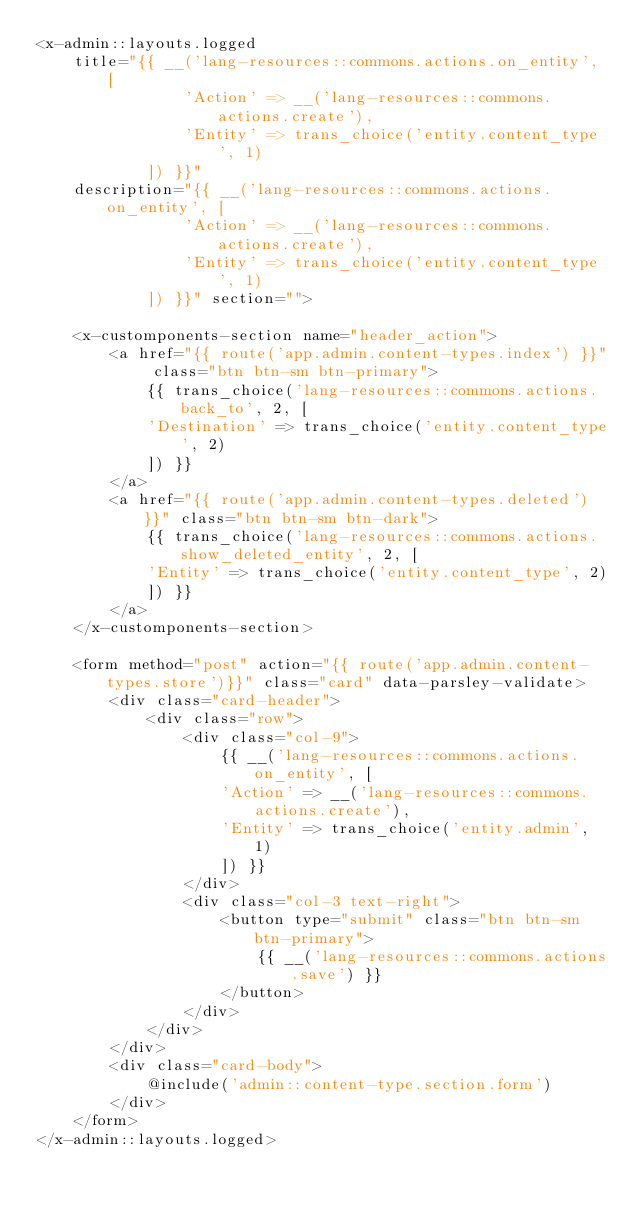Convert code to text. <code><loc_0><loc_0><loc_500><loc_500><_PHP_><x-admin::layouts.logged 
    title="{{ __('lang-resources::commons.actions.on_entity', [
                'Action' => __('lang-resources::commons.actions.create'),
                'Entity' => trans_choice('entity.content_type', 1)
            ]) }}"
    description="{{ __('lang-resources::commons.actions.on_entity', [
                'Action' => __('lang-resources::commons.actions.create'),
                'Entity' => trans_choice('entity.content_type', 1)
            ]) }}" section="">

    <x-customponents-section name="header_action">
        <a href="{{ route('app.admin.content-types.index') }}" class="btn btn-sm btn-primary">
            {{ trans_choice('lang-resources::commons.actions.back_to', 2, [
            'Destination' => trans_choice('entity.content_type', 2)
            ]) }}
        </a>
        <a href="{{ route('app.admin.content-types.deleted') }}" class="btn btn-sm btn-dark">
            {{ trans_choice('lang-resources::commons.actions.show_deleted_entity', 2, [
            'Entity' => trans_choice('entity.content_type', 2)
            ]) }}
        </a>
    </x-customponents-section>

    <form method="post" action="{{ route('app.admin.content-types.store')}}" class="card" data-parsley-validate>
        <div class="card-header">
            <div class="row">
                <div class="col-9">
                    {{ __('lang-resources::commons.actions.on_entity', [
                    'Action' => __('lang-resources::commons.actions.create'),
                    'Entity' => trans_choice('entity.admin', 1)
                    ]) }}
                </div>
                <div class="col-3 text-right">
                    <button type="submit" class="btn btn-sm btn-primary">
                        {{ __('lang-resources::commons.actions.save') }}
                    </button>
                </div>
            </div>
        </div>
        <div class="card-body">
            @include('admin::content-type.section.form')
        </div>
    </form>
</x-admin::layouts.logged></code> 